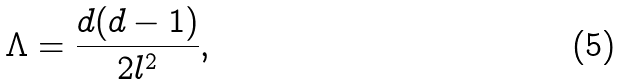<formula> <loc_0><loc_0><loc_500><loc_500>\Lambda = \frac { d ( d - 1 ) } { 2 l ^ { 2 } } ,</formula> 